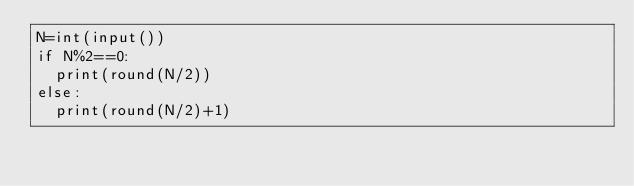<code> <loc_0><loc_0><loc_500><loc_500><_Python_>N=int(input())
if N%2==0:
	print(round(N/2))
else:
	print(round(N/2)+1)</code> 